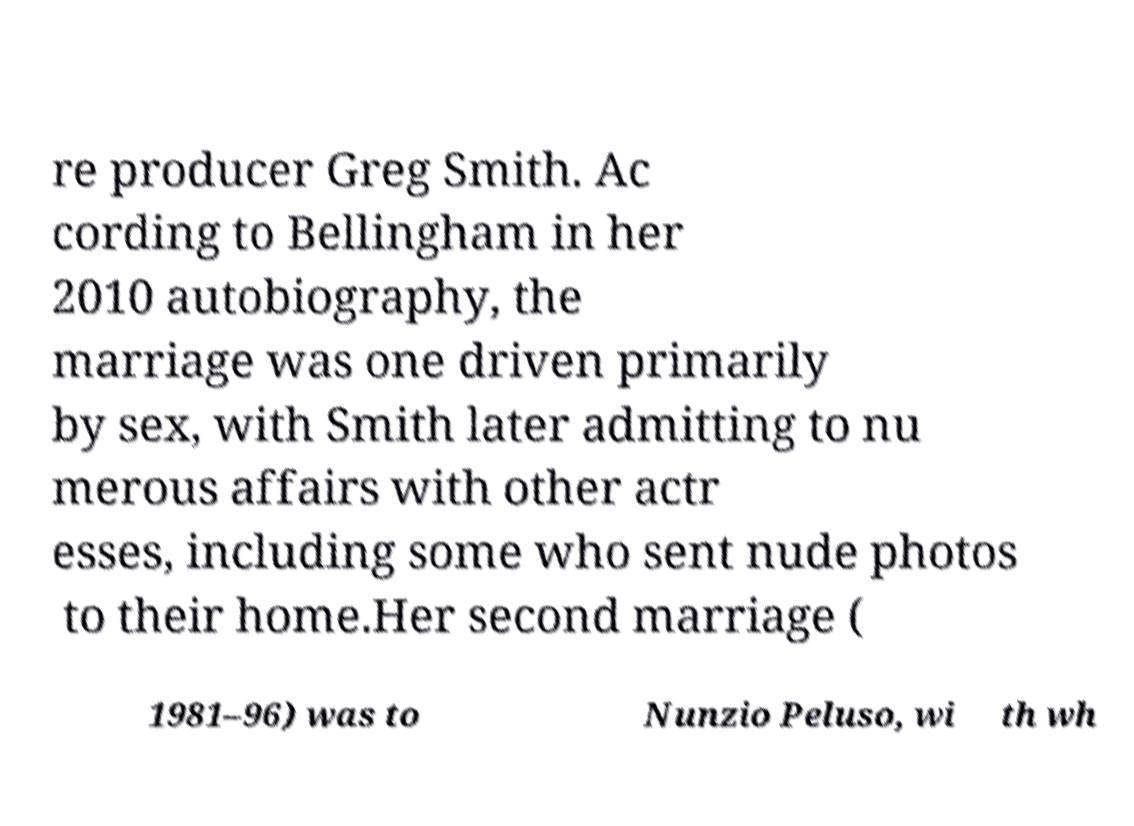What messages or text are displayed in this image? I need them in a readable, typed format. re producer Greg Smith. Ac cording to Bellingham in her 2010 autobiography, the marriage was one driven primarily by sex, with Smith later admitting to nu merous affairs with other actr esses, including some who sent nude photos to their home.Her second marriage ( 1981–96) was to Nunzio Peluso, wi th wh 